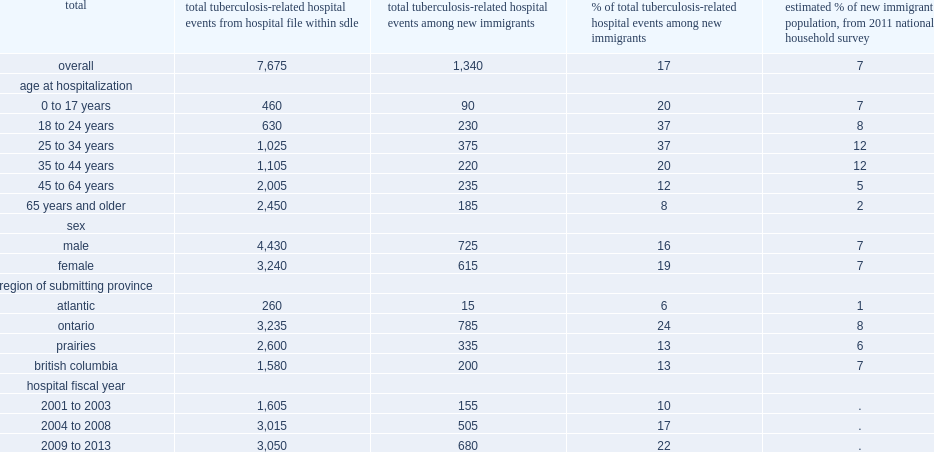What was the percentage of tb-related hospitalizations occurred to immigrants who arrived in canada from 2000 to 2013? 17.0. What was the total number of tb-related hospitalizations occurred to immigrants who arrived in canada from 2000 to 2013? 7675.0. What was the percentage of immigrants arriving during this 13-year period? 7.0. What was the percentage of the tb-related hospitallizations among recent immigrants to ontario? 24.0. 